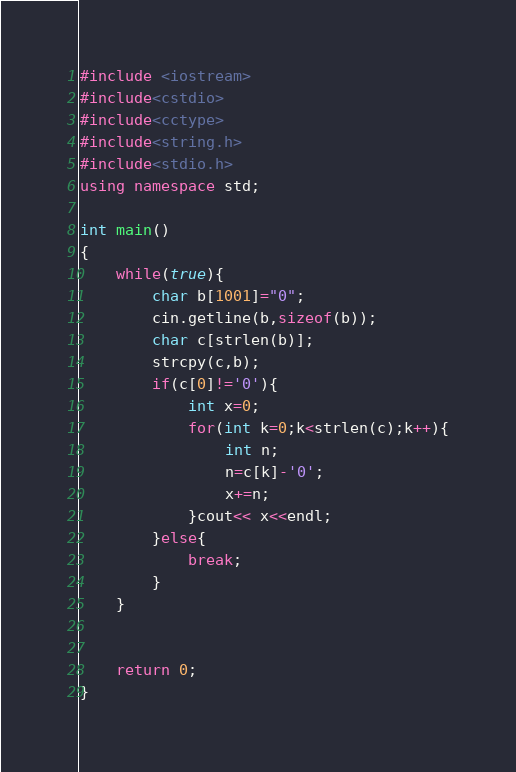Convert code to text. <code><loc_0><loc_0><loc_500><loc_500><_C++_>#include <iostream>
#include<cstdio>
#include<cctype>
#include<string.h>
#include<stdio.h>
using namespace std;

int main()
{
    while(true){
        char b[1001]="0";
        cin.getline(b,sizeof(b));
        char c[strlen(b)];
        strcpy(c,b);
        if(c[0]!='0'){
            int x=0;
            for(int k=0;k<strlen(c);k++){
                int n;
                n=c[k]-'0';
                x+=n;
            }cout<< x<<endl;
        }else{
            break;
        }
    }

    
    return 0;
}
</code> 